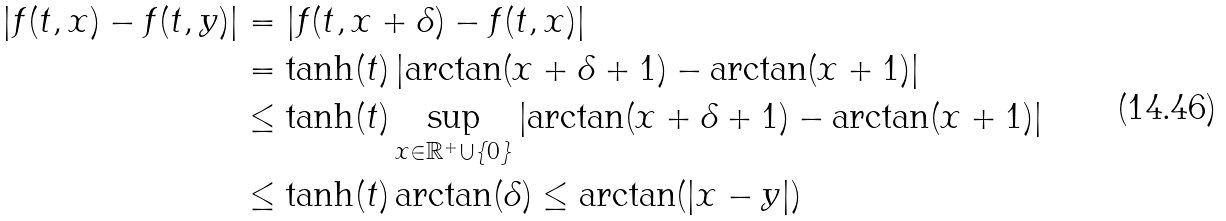<formula> <loc_0><loc_0><loc_500><loc_500>| f ( t , x ) - f ( t , y ) | & = | f ( t , x + \delta ) - f ( t , x ) | \\ & = \tanh ( t ) \left | \arctan ( x + \delta + 1 ) - \arctan ( x + 1 ) \right | \\ & \leq \tanh ( t ) \sup _ { x \in \mathbb { R } ^ { + } \cup \{ 0 \} } \left | \arctan ( x + \delta + 1 ) - \arctan ( x + 1 ) \right | \\ & \leq \tanh ( t ) \arctan ( \delta ) \leq \arctan ( | x - y | )</formula> 